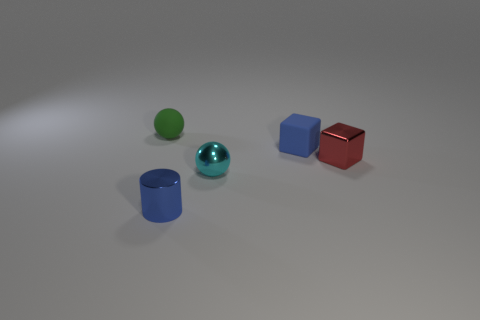Add 3 tiny blue rubber blocks. How many objects exist? 8 Subtract all red cubes. How many cubes are left? 1 Subtract 2 balls. How many balls are left? 0 Subtract all green balls. Subtract all purple cubes. How many balls are left? 1 Subtract all blue blocks. How many red balls are left? 0 Subtract all blue shiny things. Subtract all large brown rubber blocks. How many objects are left? 4 Add 2 small metallic cylinders. How many small metallic cylinders are left? 3 Add 1 large yellow metallic cylinders. How many large yellow metallic cylinders exist? 1 Subtract 0 green cubes. How many objects are left? 5 Subtract all blocks. How many objects are left? 3 